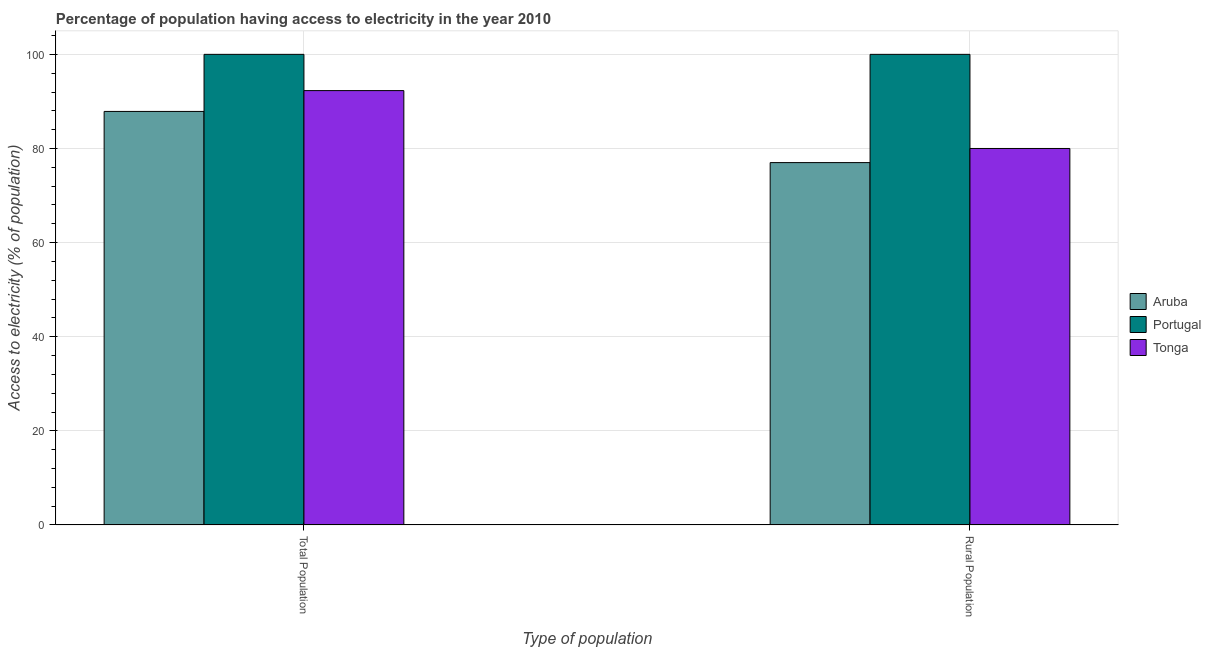How many different coloured bars are there?
Provide a short and direct response. 3. How many groups of bars are there?
Ensure brevity in your answer.  2. Are the number of bars per tick equal to the number of legend labels?
Make the answer very short. Yes. How many bars are there on the 1st tick from the left?
Your response must be concise. 3. What is the label of the 1st group of bars from the left?
Provide a short and direct response. Total Population. What is the percentage of population having access to electricity in Tonga?
Provide a short and direct response. 92.3. Across all countries, what is the minimum percentage of population having access to electricity?
Your answer should be compact. 87.87. In which country was the percentage of population having access to electricity minimum?
Ensure brevity in your answer.  Aruba. What is the total percentage of rural population having access to electricity in the graph?
Offer a very short reply. 257. What is the difference between the percentage of rural population having access to electricity in Portugal and that in Aruba?
Make the answer very short. 23. What is the difference between the percentage of population having access to electricity in Tonga and the percentage of rural population having access to electricity in Portugal?
Offer a terse response. -7.7. What is the average percentage of population having access to electricity per country?
Keep it short and to the point. 93.39. What is the ratio of the percentage of population having access to electricity in Tonga to that in Portugal?
Provide a short and direct response. 0.92. Is the percentage of rural population having access to electricity in Tonga less than that in Aruba?
Provide a short and direct response. No. In how many countries, is the percentage of population having access to electricity greater than the average percentage of population having access to electricity taken over all countries?
Provide a succinct answer. 1. What does the 3rd bar from the left in Total Population represents?
Make the answer very short. Tonga. What does the 1st bar from the right in Rural Population represents?
Make the answer very short. Tonga. How many bars are there?
Offer a very short reply. 6. How many countries are there in the graph?
Offer a terse response. 3. Where does the legend appear in the graph?
Give a very brief answer. Center right. How many legend labels are there?
Your answer should be compact. 3. How are the legend labels stacked?
Offer a very short reply. Vertical. What is the title of the graph?
Make the answer very short. Percentage of population having access to electricity in the year 2010. Does "Tajikistan" appear as one of the legend labels in the graph?
Offer a terse response. No. What is the label or title of the X-axis?
Ensure brevity in your answer.  Type of population. What is the label or title of the Y-axis?
Provide a succinct answer. Access to electricity (% of population). What is the Access to electricity (% of population) of Aruba in Total Population?
Keep it short and to the point. 87.87. What is the Access to electricity (% of population) in Portugal in Total Population?
Your answer should be compact. 100. What is the Access to electricity (% of population) in Tonga in Total Population?
Offer a very short reply. 92.3. What is the Access to electricity (% of population) in Portugal in Rural Population?
Ensure brevity in your answer.  100. What is the Access to electricity (% of population) of Tonga in Rural Population?
Provide a short and direct response. 80. Across all Type of population, what is the maximum Access to electricity (% of population) in Aruba?
Give a very brief answer. 87.87. Across all Type of population, what is the maximum Access to electricity (% of population) in Portugal?
Ensure brevity in your answer.  100. Across all Type of population, what is the maximum Access to electricity (% of population) of Tonga?
Your response must be concise. 92.3. What is the total Access to electricity (% of population) in Aruba in the graph?
Make the answer very short. 164.87. What is the total Access to electricity (% of population) in Tonga in the graph?
Offer a very short reply. 172.3. What is the difference between the Access to electricity (% of population) of Aruba in Total Population and that in Rural Population?
Provide a short and direct response. 10.87. What is the difference between the Access to electricity (% of population) in Aruba in Total Population and the Access to electricity (% of population) in Portugal in Rural Population?
Provide a short and direct response. -12.13. What is the difference between the Access to electricity (% of population) in Aruba in Total Population and the Access to electricity (% of population) in Tonga in Rural Population?
Your response must be concise. 7.87. What is the difference between the Access to electricity (% of population) of Portugal in Total Population and the Access to electricity (% of population) of Tonga in Rural Population?
Provide a short and direct response. 20. What is the average Access to electricity (% of population) of Aruba per Type of population?
Your response must be concise. 82.44. What is the average Access to electricity (% of population) of Portugal per Type of population?
Offer a very short reply. 100. What is the average Access to electricity (% of population) of Tonga per Type of population?
Your answer should be compact. 86.15. What is the difference between the Access to electricity (% of population) of Aruba and Access to electricity (% of population) of Portugal in Total Population?
Your answer should be compact. -12.13. What is the difference between the Access to electricity (% of population) of Aruba and Access to electricity (% of population) of Tonga in Total Population?
Keep it short and to the point. -4.43. What is the difference between the Access to electricity (% of population) in Aruba and Access to electricity (% of population) in Portugal in Rural Population?
Offer a very short reply. -23. What is the difference between the Access to electricity (% of population) in Portugal and Access to electricity (% of population) in Tonga in Rural Population?
Keep it short and to the point. 20. What is the ratio of the Access to electricity (% of population) of Aruba in Total Population to that in Rural Population?
Give a very brief answer. 1.14. What is the ratio of the Access to electricity (% of population) in Tonga in Total Population to that in Rural Population?
Your response must be concise. 1.15. What is the difference between the highest and the second highest Access to electricity (% of population) in Aruba?
Make the answer very short. 10.87. What is the difference between the highest and the second highest Access to electricity (% of population) in Portugal?
Make the answer very short. 0. What is the difference between the highest and the lowest Access to electricity (% of population) of Aruba?
Make the answer very short. 10.87. What is the difference between the highest and the lowest Access to electricity (% of population) of Portugal?
Ensure brevity in your answer.  0. What is the difference between the highest and the lowest Access to electricity (% of population) in Tonga?
Offer a terse response. 12.3. 